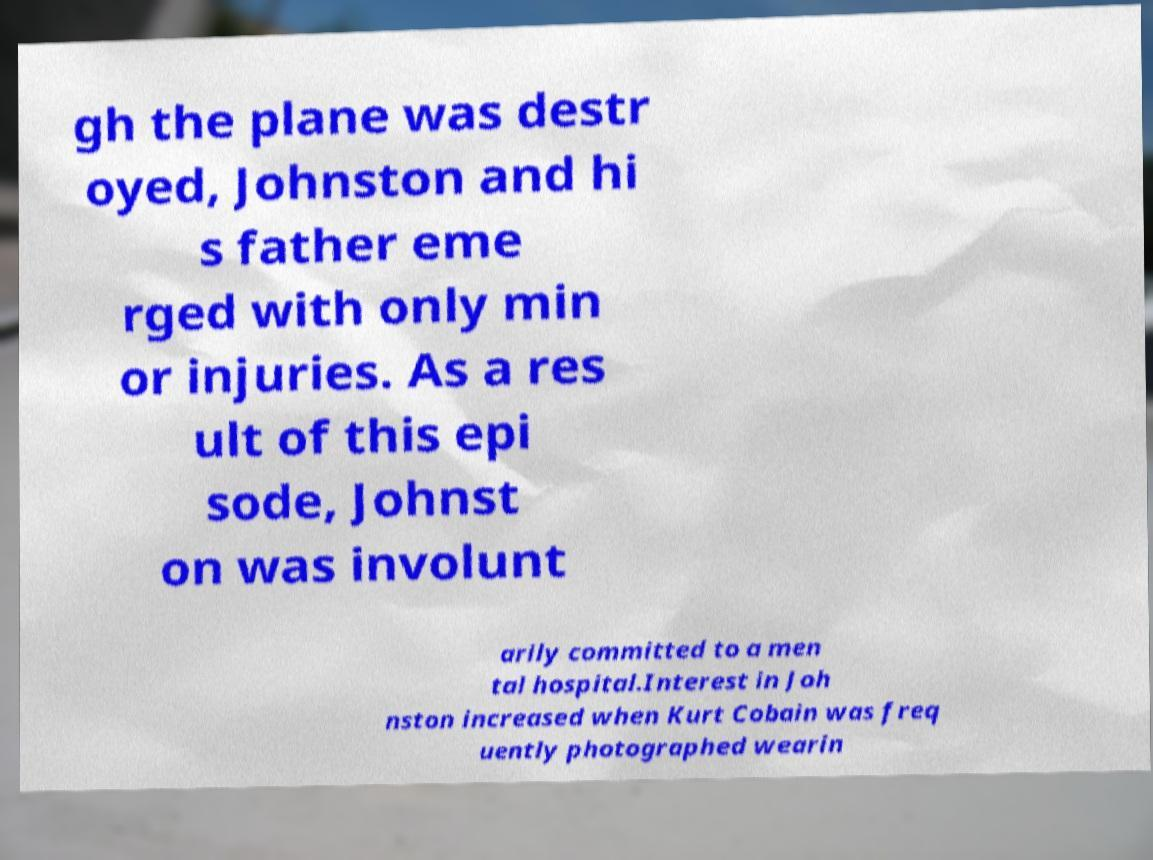I need the written content from this picture converted into text. Can you do that? gh the plane was destr oyed, Johnston and hi s father eme rged with only min or injuries. As a res ult of this epi sode, Johnst on was involunt arily committed to a men tal hospital.Interest in Joh nston increased when Kurt Cobain was freq uently photographed wearin 